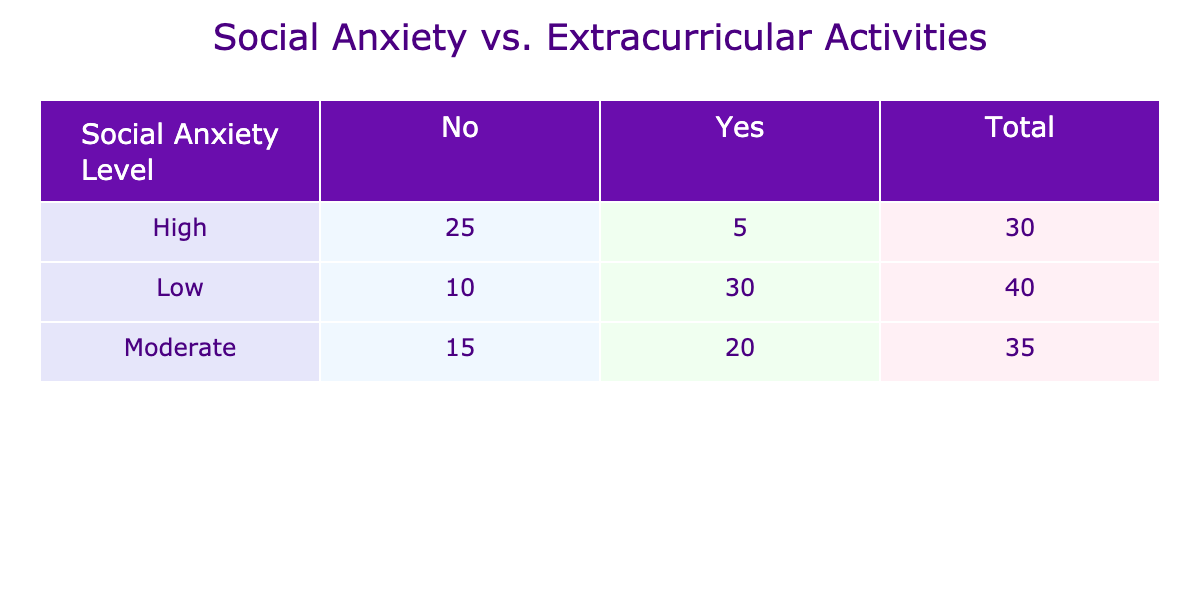What is the total number of participants with a low social anxiety level? In the table, under the "Low" social anxiety level, there are two entries: "Yes" and "No." The count for "Yes" is 30 and for "No" it is 10. Adding these together gives 30 + 10 = 40.
Answer: 40 What is the count of people with high social anxiety who participate in extracurricular activities? According to the table, under "High" social anxiety level, the count for "Yes" participation is 5. This is the answer since only that count is pertinent to the question.
Answer: 5 What percentage of individuals with moderate social anxiety participate in extracurricular activities? For the moderate level, the count of those who participate "Yes" is 20, and "No" is 15. The total for moderate anxiety is 20 + 15 = 35. The percentage participating is (20/35) * 100 = 57.14%.
Answer: 57.14% Is there a higher count of people with high social anxiety levels who do not participate in extracurricular activities than those who do? In the table, for high social anxiety, the count for "No" is 25 and for "Yes" is 5. Since 25 > 5, the statement is true.
Answer: Yes How many more individuals with low social anxiety participate in activities compared to those with high social anxiety who do? From the table, those with low social anxiety who participate "Yes" is 30, and those with high social anxiety who do is 5. The difference is 30 - 5 = 25.
Answer: 25 What is the total count of individuals who do not participate in extracurricular activities across all anxiety levels? We need to sum the counts of individuals who answered "No" for each level: Low (10), Moderate (15), and High (25). So, the total is 10 + 15 + 25 = 50.
Answer: 50 How many individuals participate in extracurricular activities at a moderate level of social anxiety? The count of individuals with moderate social anxiety who participate is listed under "Yes," which is 20. This is a direct retrieval from the table.
Answer: 20 Is the majority of individuals with social anxiety low or high more likely to participate in extracurricular activities? We compare the "Yes" counts for low (30) and high (5). 30 is greater than 5, indicating that the majority is low anxiety participants. Therefore, they are more likely to participate.
Answer: Low 